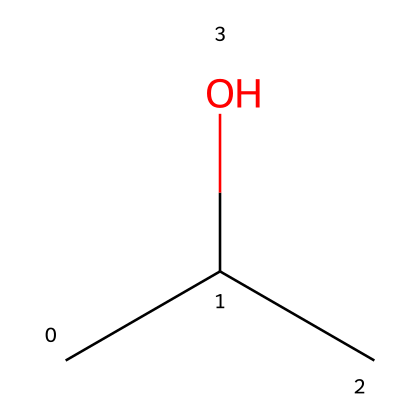How many carbon atoms are present in isopropyl alcohol? The SMILES representation "CC(C)O" indicates there are three carbon atoms (C). The letter 'C' represents a carbon atom, and each 'C' in this structure counts as one atom.
Answer: three What functional group is present in isopropyl alcohol? In the chemical structure represented by "CC(C)O", the presence of the hydroxyl group (-OH) is indicated by the 'O' at the end of the SMILES notation. This functional group classifies it as an alcohol.
Answer: hydroxyl What is the molecular formula of isopropyl alcohol? Based on the structure "CC(C)O", the molecular formula can be derived by counting the carbon (C), hydrogen (H), and oxygen (O) atoms. There are three carbons, eight hydrogens, and one oxygen, leading to the formula C3H8O.
Answer: C3H8O Is isopropyl alcohol a polar or non-polar solvent? The presence of the hydroxyl group (-OH) causes isopropyl alcohol to have polar characteristics due to the electronegativity difference between oxygen and hydrogen. This results in a polar solvent.
Answer: polar What is the boiling point of isopropyl alcohol? Isopropyl alcohol typically boils at around 82.6 degrees Celsius. This property can be found in common chemical literature regarding alcohols.
Answer: 82.6 degrees Celsius How many hydrogen atoms are in isopropyl alcohol? By analyzing the SMILES "CC(C)O", we can deduce that there are eight hydrogen atoms attached to the three carbon atoms and the hydroxyl group in the structure, following the saturation rules for carbon.
Answer: eight What property of isopropyl alcohol makes it suitable for cleaning electronic devices? The polar nature and the ability to dissolve oils and fats, combined with its volatility (quick evaporation without residue), make isopropyl alcohol effective for cleaning electronic devices.
Answer: dissolves oils 